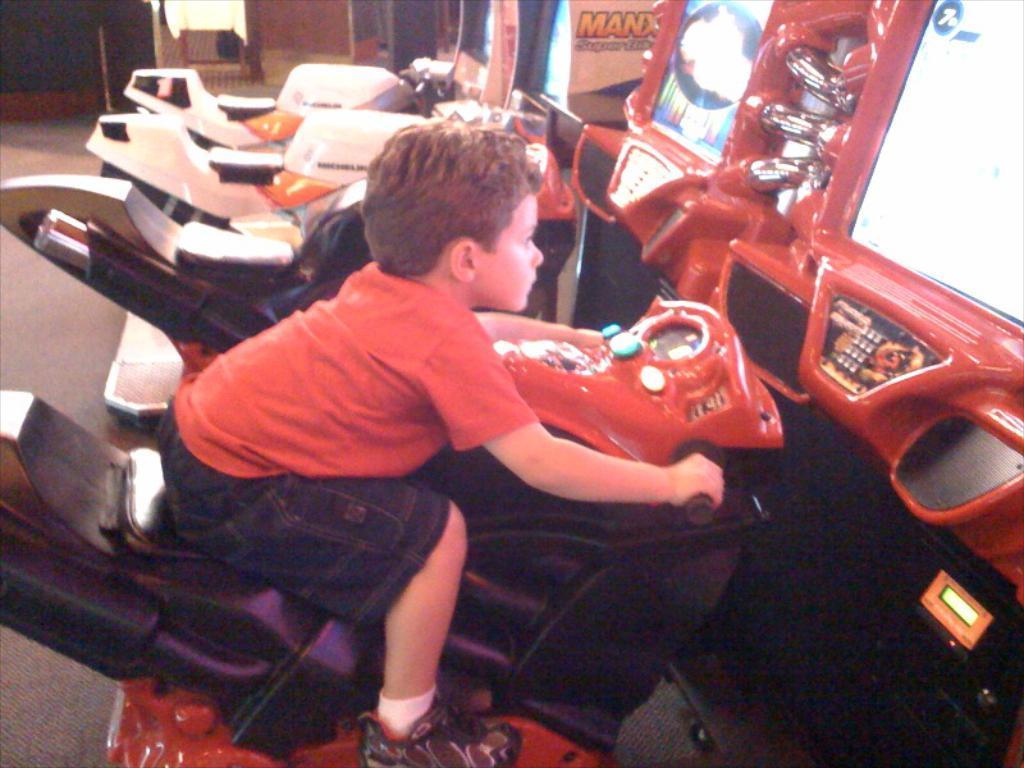Could you give a brief overview of what you see in this image? In front of the image there is a boy riding the bike. Beside him there are a few other bikes. In front of him there are game stations. 